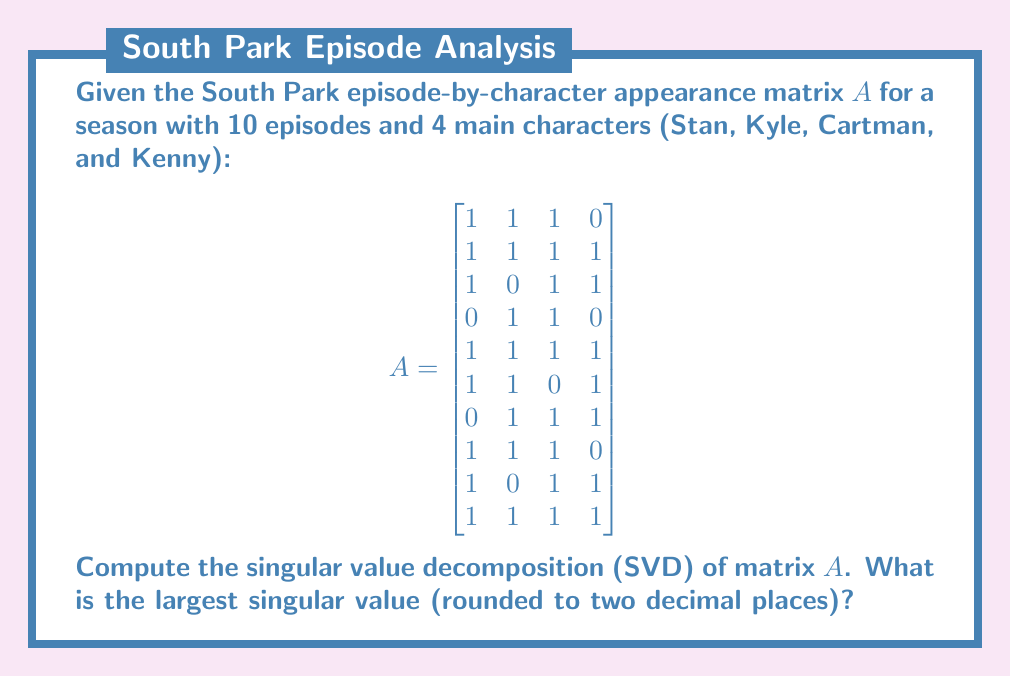Can you solve this math problem? To compute the singular value decomposition of matrix $A$, we need to follow these steps:

1) First, calculate $A^TA$:
   $$A^TA = \begin{bmatrix}
   8 & 6 & 7 & 5 \\
   6 & 8 & 7 & 5 \\
   7 & 7 & 9 & 6 \\
   5 & 5 & 6 & 7
   \end{bmatrix}$$

2) Find the eigenvalues of $A^TA$ by solving the characteristic equation:
   $\det(A^TA - \lambda I) = 0$

3) The eigenvalues are approximately:
   $\lambda_1 \approx 28.0534$
   $\lambda_2 \approx 2.7466$
   $\lambda_3 \approx 0.9309$
   $\lambda_4 \approx 0.2691$

4) The singular values are the square roots of these eigenvalues:
   $\sigma_1 \approx \sqrt{28.0534} \approx 5.2966$
   $\sigma_2 \approx \sqrt{2.7466} \approx 1.6573$
   $\sigma_3 \approx \sqrt{0.9309} \approx 0.9649$
   $\sigma_4 \approx \sqrt{0.2691} \approx 0.5188$

5) The largest singular value is $\sigma_1 \approx 5.2966$, which rounded to two decimal places is 5.30.

Note: The full SVD would also involve calculating the left and right singular vectors, but the question only asks for the largest singular value.
Answer: 5.30 